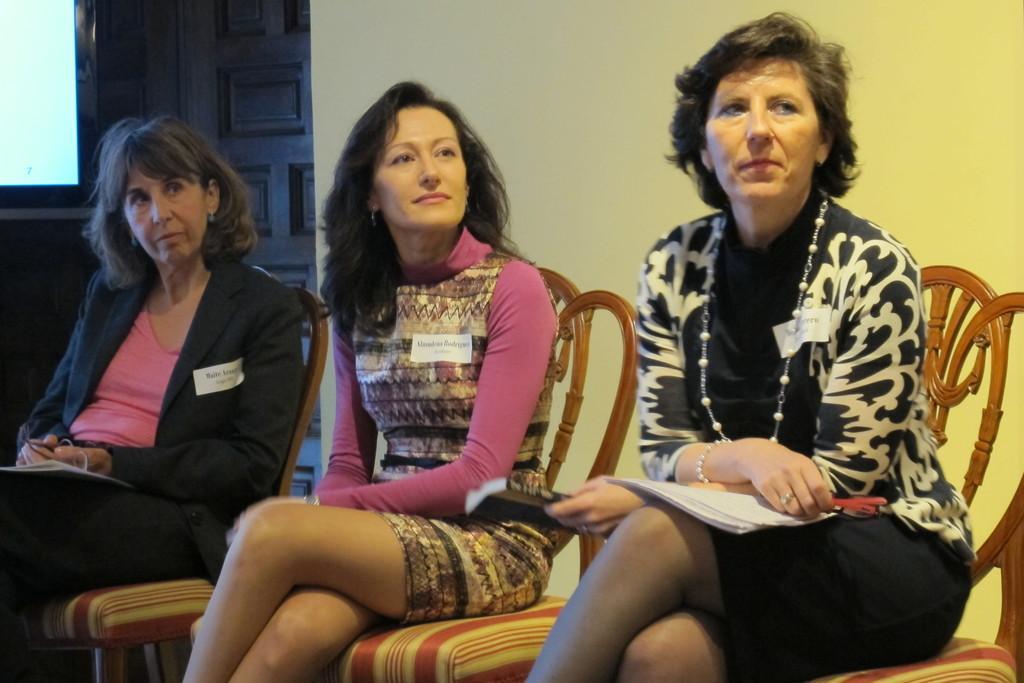Could you give a brief overview of what you see in this image? In this picture we can see three women, they are sitting on the chairs and the right side woman is holding a book. 